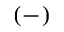Convert formula to latex. <formula><loc_0><loc_0><loc_500><loc_500>( - )</formula> 